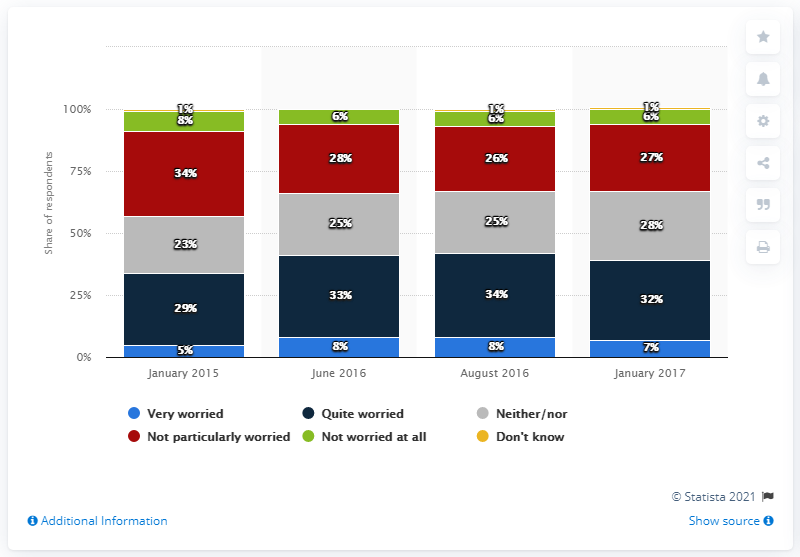Mention a couple of crucial points in this snapshot. In January 2017, 7% of respondents expressed concern about the likelihood of a terror attack in Sweden, indicating high levels of anxiety about this possibility. 